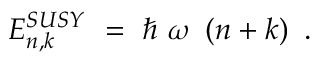Convert formula to latex. <formula><loc_0><loc_0><loc_500><loc_500>E _ { n , k } ^ { S U S Y } = \hbar { \omega } \left ( n + k \right ) .</formula> 